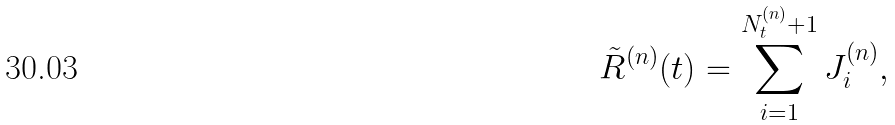Convert formula to latex. <formula><loc_0><loc_0><loc_500><loc_500>\tilde { R } ^ { ( n ) } ( t ) = \sum _ { i = 1 } ^ { N ^ { ( n ) } _ { t } + 1 } J ^ { ( n ) } _ { i } ,</formula> 